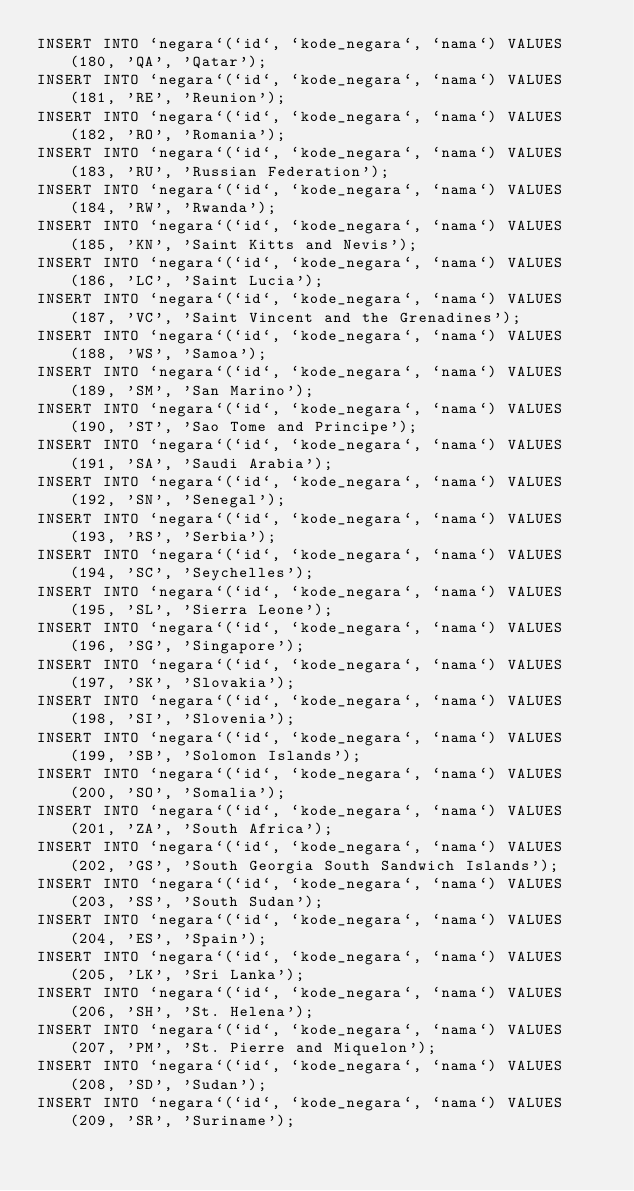<code> <loc_0><loc_0><loc_500><loc_500><_SQL_>INSERT INTO `negara`(`id`, `kode_negara`, `nama`) VALUES (180, 'QA', 'Qatar');
INSERT INTO `negara`(`id`, `kode_negara`, `nama`) VALUES (181, 'RE', 'Reunion');
INSERT INTO `negara`(`id`, `kode_negara`, `nama`) VALUES (182, 'RO', 'Romania');
INSERT INTO `negara`(`id`, `kode_negara`, `nama`) VALUES (183, 'RU', 'Russian Federation');
INSERT INTO `negara`(`id`, `kode_negara`, `nama`) VALUES (184, 'RW', 'Rwanda');
INSERT INTO `negara`(`id`, `kode_negara`, `nama`) VALUES (185, 'KN', 'Saint Kitts and Nevis');
INSERT INTO `negara`(`id`, `kode_negara`, `nama`) VALUES (186, 'LC', 'Saint Lucia');
INSERT INTO `negara`(`id`, `kode_negara`, `nama`) VALUES (187, 'VC', 'Saint Vincent and the Grenadines');
INSERT INTO `negara`(`id`, `kode_negara`, `nama`) VALUES (188, 'WS', 'Samoa');
INSERT INTO `negara`(`id`, `kode_negara`, `nama`) VALUES (189, 'SM', 'San Marino');
INSERT INTO `negara`(`id`, `kode_negara`, `nama`) VALUES (190, 'ST', 'Sao Tome and Principe');
INSERT INTO `negara`(`id`, `kode_negara`, `nama`) VALUES (191, 'SA', 'Saudi Arabia');
INSERT INTO `negara`(`id`, `kode_negara`, `nama`) VALUES (192, 'SN', 'Senegal');
INSERT INTO `negara`(`id`, `kode_negara`, `nama`) VALUES (193, 'RS', 'Serbia');
INSERT INTO `negara`(`id`, `kode_negara`, `nama`) VALUES (194, 'SC', 'Seychelles');
INSERT INTO `negara`(`id`, `kode_negara`, `nama`) VALUES (195, 'SL', 'Sierra Leone');
INSERT INTO `negara`(`id`, `kode_negara`, `nama`) VALUES (196, 'SG', 'Singapore');
INSERT INTO `negara`(`id`, `kode_negara`, `nama`) VALUES (197, 'SK', 'Slovakia');
INSERT INTO `negara`(`id`, `kode_negara`, `nama`) VALUES (198, 'SI', 'Slovenia');
INSERT INTO `negara`(`id`, `kode_negara`, `nama`) VALUES (199, 'SB', 'Solomon Islands');
INSERT INTO `negara`(`id`, `kode_negara`, `nama`) VALUES (200, 'SO', 'Somalia');
INSERT INTO `negara`(`id`, `kode_negara`, `nama`) VALUES (201, 'ZA', 'South Africa');
INSERT INTO `negara`(`id`, `kode_negara`, `nama`) VALUES (202, 'GS', 'South Georgia South Sandwich Islands');
INSERT INTO `negara`(`id`, `kode_negara`, `nama`) VALUES (203, 'SS', 'South Sudan');
INSERT INTO `negara`(`id`, `kode_negara`, `nama`) VALUES (204, 'ES', 'Spain');
INSERT INTO `negara`(`id`, `kode_negara`, `nama`) VALUES (205, 'LK', 'Sri Lanka');
INSERT INTO `negara`(`id`, `kode_negara`, `nama`) VALUES (206, 'SH', 'St. Helena');
INSERT INTO `negara`(`id`, `kode_negara`, `nama`) VALUES (207, 'PM', 'St. Pierre and Miquelon');
INSERT INTO `negara`(`id`, `kode_negara`, `nama`) VALUES (208, 'SD', 'Sudan');
INSERT INTO `negara`(`id`, `kode_negara`, `nama`) VALUES (209, 'SR', 'Suriname');</code> 